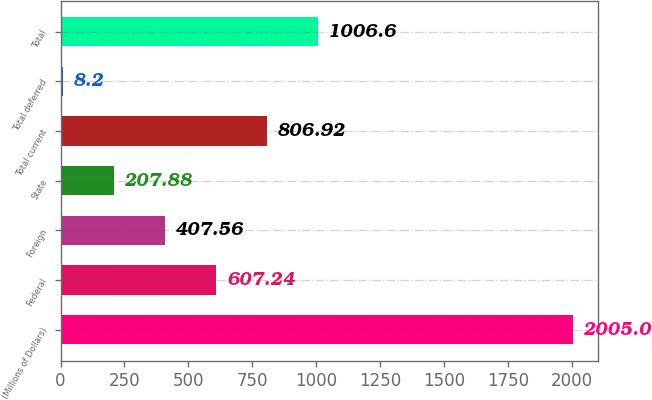Convert chart to OTSL. <chart><loc_0><loc_0><loc_500><loc_500><bar_chart><fcel>(Millions of Dollars)<fcel>Federal<fcel>Foreign<fcel>State<fcel>Total current<fcel>Total deferred<fcel>Total<nl><fcel>2005<fcel>607.24<fcel>407.56<fcel>207.88<fcel>806.92<fcel>8.2<fcel>1006.6<nl></chart> 